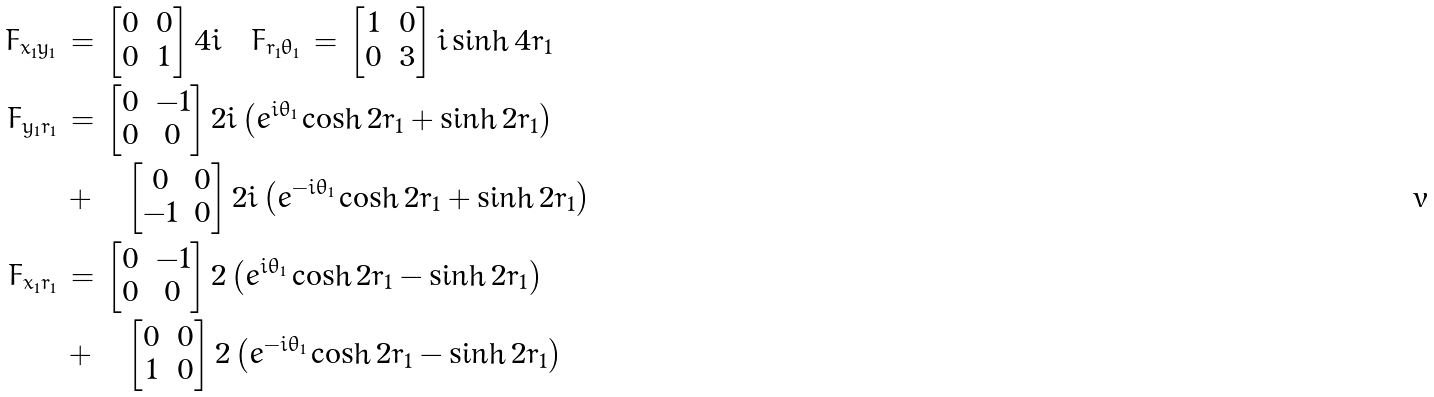<formula> <loc_0><loc_0><loc_500><loc_500>F _ { x _ { 1 } y _ { 1 } } \, & = \, \left [ \begin{matrix} 0 & 0 \\ 0 & 1 \end{matrix} \right ] 4 i \quad F _ { r _ { 1 } \theta _ { 1 } } \, = \, \left [ \begin{matrix} 1 & 0 \\ 0 & 3 \end{matrix} \right ] i \sinh 4 r _ { 1 } \\ F _ { y _ { 1 } r _ { 1 } } \, & = \, \left [ \begin{matrix} 0 & - 1 \\ 0 & 0 \\ \end{matrix} \right ] 2 i \left ( e ^ { i \theta _ { 1 } } \cosh 2 r _ { 1 } + \sinh 2 r _ { 1 } \right ) \\ & + \quad \left [ \begin{matrix} 0 & 0 \\ - 1 & 0 \\ \end{matrix} \right ] 2 i \left ( e ^ { - i \theta _ { 1 } } \cosh 2 r _ { 1 } + \sinh 2 r _ { 1 } \right ) \\ F _ { x _ { 1 } r _ { 1 } } \, & = \, \left [ \begin{matrix} 0 & - 1 \\ 0 & 0 \\ \end{matrix} \right ] 2 \left ( e ^ { i \theta _ { 1 } } \cosh 2 r _ { 1 } - \sinh 2 r _ { 1 } \right ) \\ & + \quad \left [ \begin{matrix} 0 & 0 \\ 1 & 0 \\ \end{matrix} \right ] 2 \left ( e ^ { - i \theta _ { 1 } } \cosh 2 r _ { 1 } - \sinh 2 r _ { 1 } \right )</formula> 